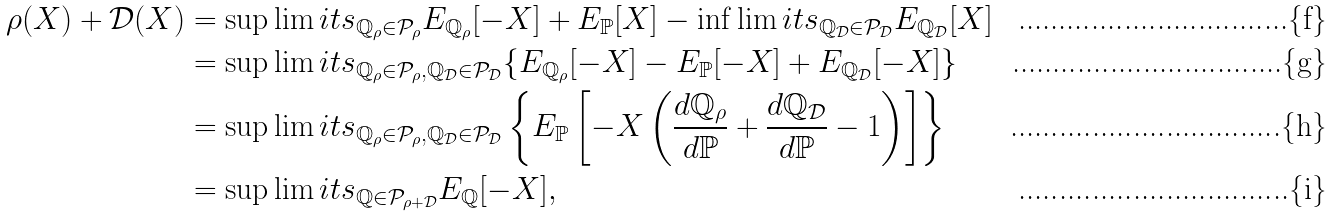Convert formula to latex. <formula><loc_0><loc_0><loc_500><loc_500>\rho ( X ) + \mathcal { D } ( X ) & = \sup \lim i t s _ { \mathbb { Q } _ { \rho } \in \mathcal { P } _ { \rho } } E _ { \mathbb { Q } _ { \rho } } [ - X ] + E _ { \mathbb { P } } [ X ] - \inf \lim i t s _ { \mathbb { Q } _ { \mathcal { D } } \in \mathcal { P } _ { \mathcal { D } } } E _ { \mathbb { Q } _ { \mathcal { D } } } [ X ] \\ & = \sup \lim i t s _ { \mathbb { Q } _ { \rho } \in \mathcal { P } _ { \rho } , \mathbb { Q } _ { \mathcal { D } } \in \mathcal { P } _ { \mathcal { D } } } \{ E _ { \mathbb { Q } _ { \rho } } [ - X ] - E _ { \mathbb { P } } [ - X ] + E _ { \mathbb { Q } _ { \mathcal { D } } } [ - X ] \} \\ & = \sup \lim i t s _ { \mathbb { Q } _ { \rho } \in \mathcal { P } _ { \rho } , \mathbb { Q } _ { \mathcal { D } } \in \mathcal { P } _ { \mathcal { D } } } \left \{ E _ { \mathbb { P } } \left [ - X \left ( \frac { d \mathbb { Q } _ { \rho } } { d \mathbb { P } } + \frac { d \mathbb { Q } _ { \mathcal { D } } } { d \mathbb { P } } - 1 \right ) \right ] \right \} \\ & = \sup \lim i t s _ { \mathbb { Q } \in \mathcal { P } _ { \rho + \mathcal { D } } } E _ { \mathbb { Q } } [ - X ] ,</formula> 